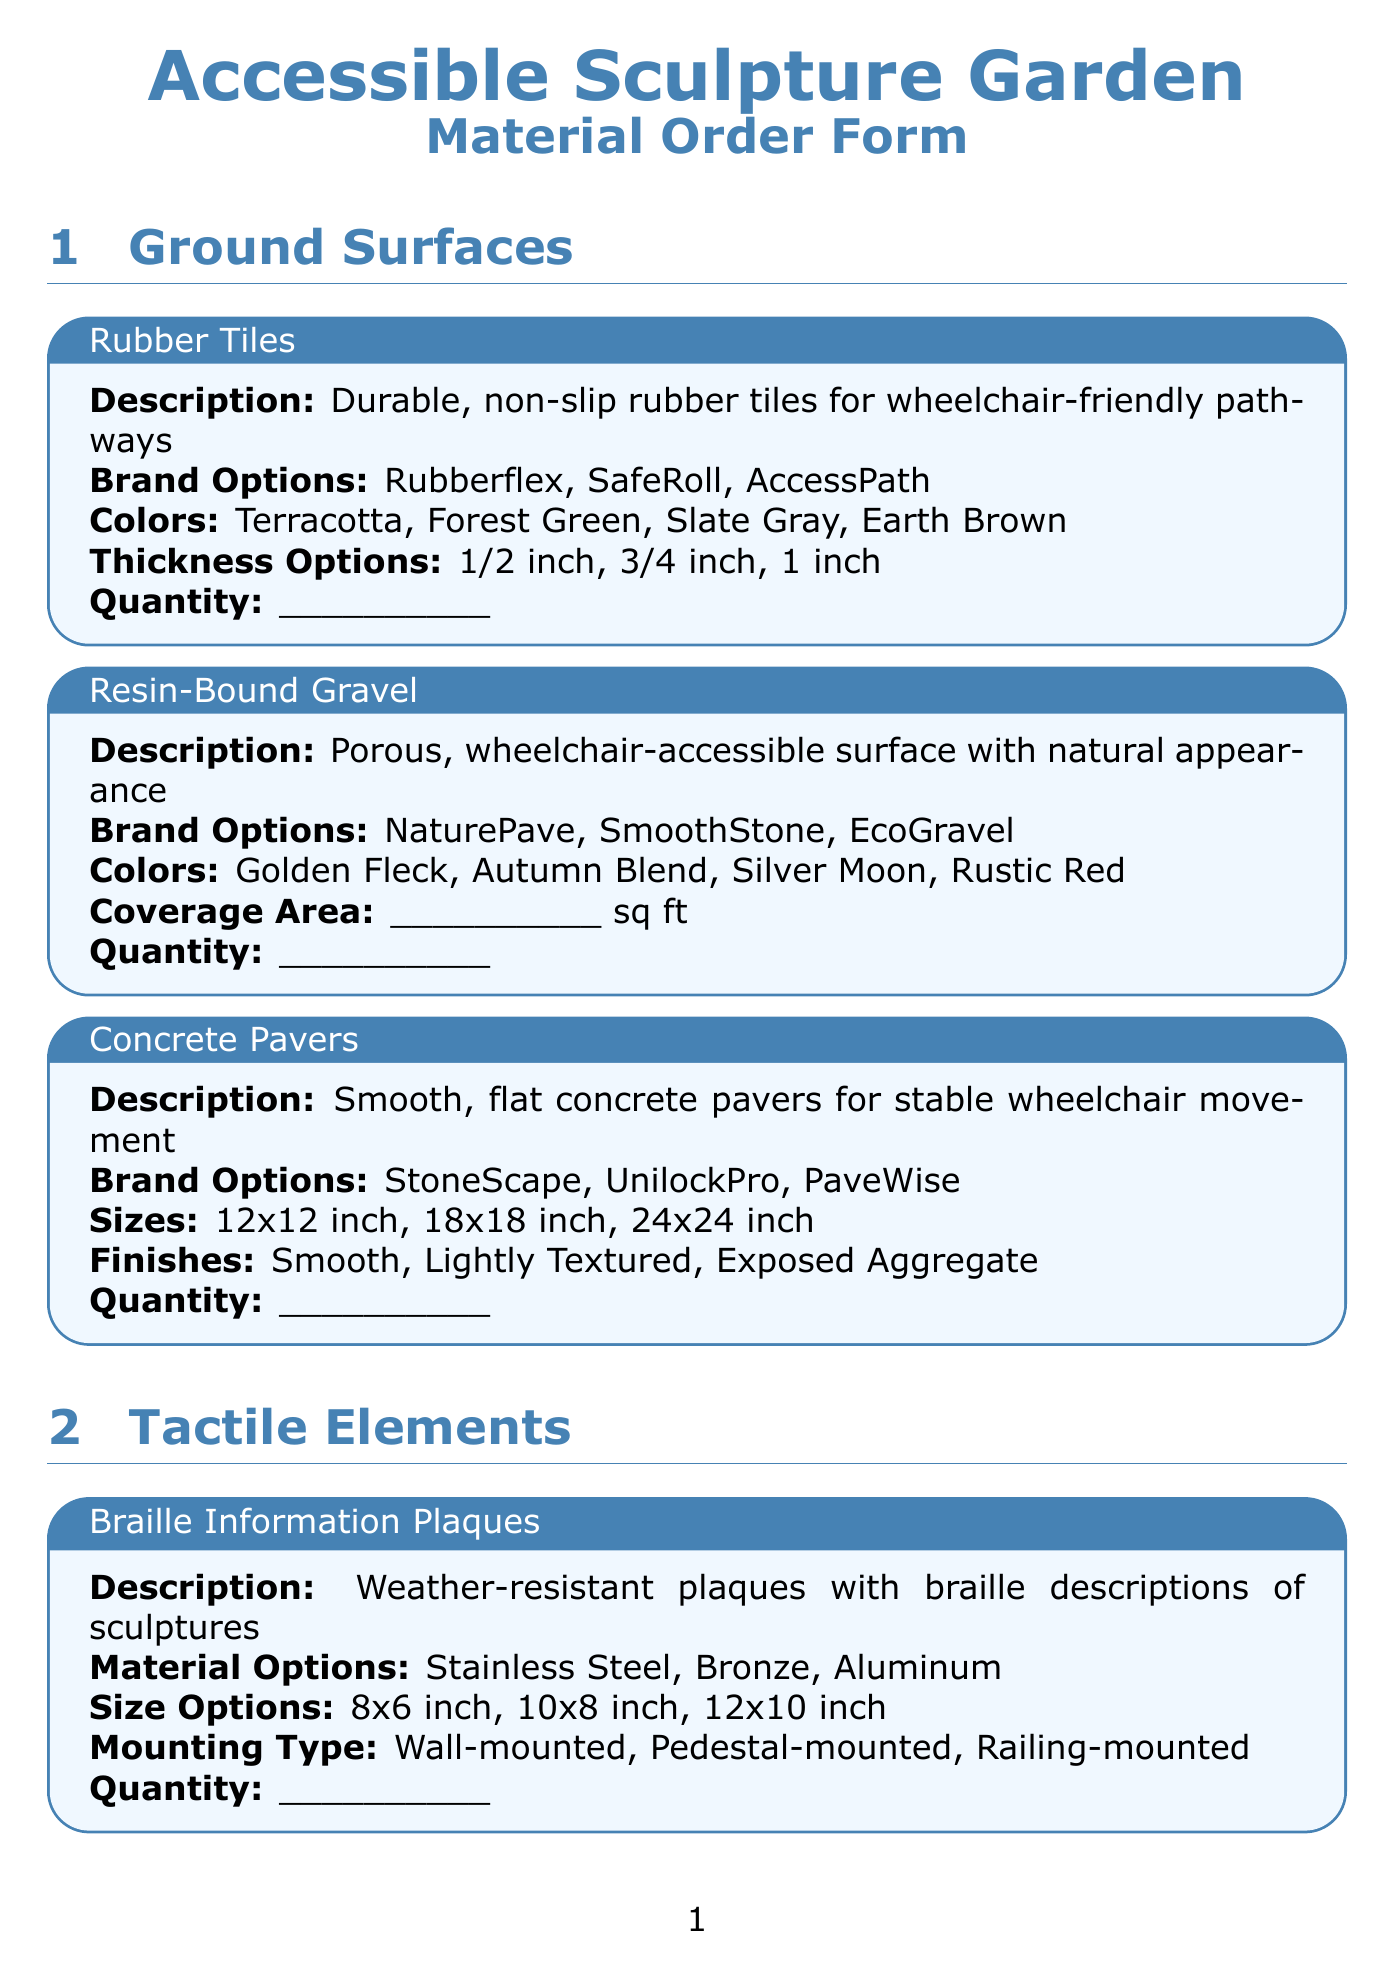what are the thickness options for Rubber Tiles? The thickness options available for Rubber Tiles are listed in the Ground Surfaces section of the document.
Answer: 1/2 inch, 3/4 inch, 1 inch what is the material for Braille Information Plaques? The material options for Braille Information Plaques are specified in the Tactile Elements section of the document.
Answer: Stainless Steel, Bronze, Aluminum how many colors are available for Textured Path Markers? The colors available for Textured Path Markers are mentioned in the description within the Tactile Elements section.
Answer: 4 what powers the Audio Description Stations? The power source options for Audio Description Stations are outlined in the Tactile Elements section of the document.
Answer: Solar, Battery, Wired what is the slope option for Ramps? The slope options for Ramps are detailed in the Accessibility Features section of the document.
Answer: 1:12, 1:16, 1:20 what type of mounting is available for Braille Information Plaques? The mounting type options for Braille Information Plaques are provided within the Tactile Elements section.
Answer: Wall-mounted, Pedestal-mounted, Railing-mounted how many sizes can Concrete Pavers be ordered in? The number of size options for Concrete Pavers is indicated in the Ground Surfaces section of the document.
Answer: 3 what is the expected finish type for Handrails? The finish options for Handrails are described in the Accessibility Features section of the document.
Answer: Brushed, Polished, Textured 